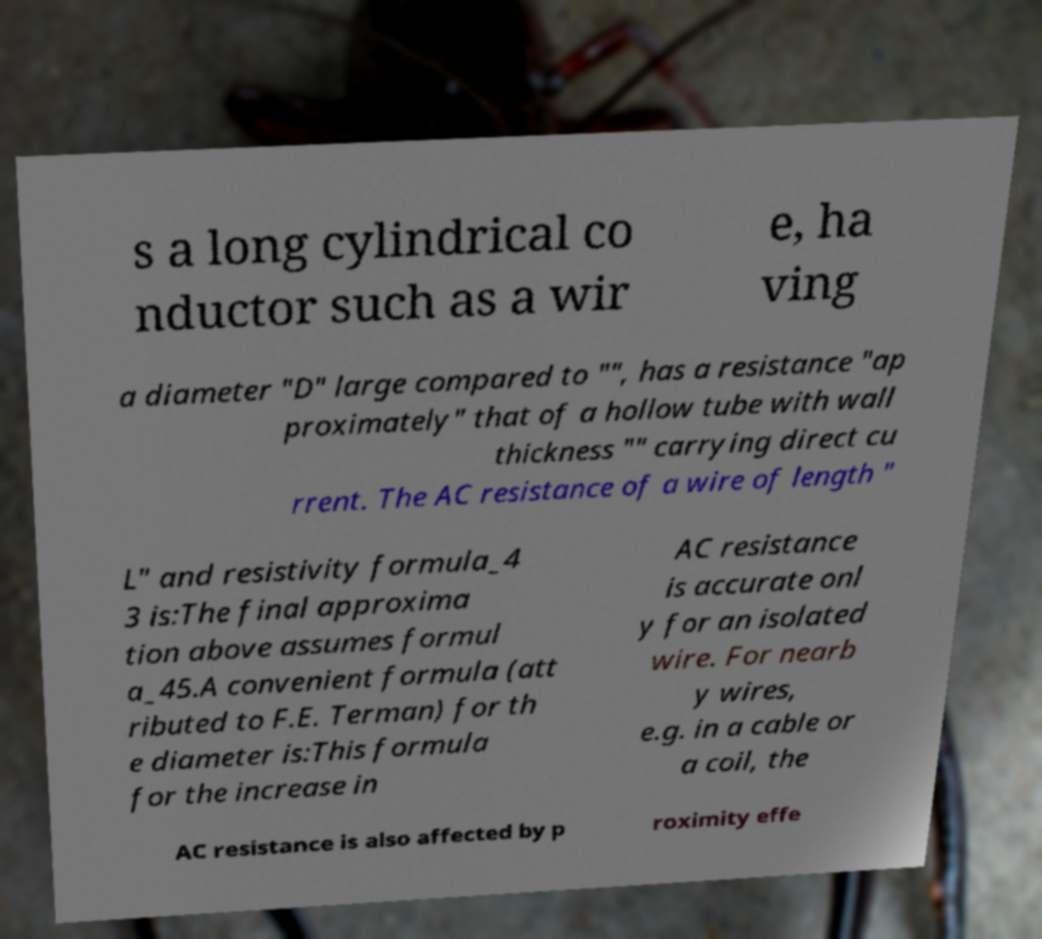Please identify and transcribe the text found in this image. s a long cylindrical co nductor such as a wir e, ha ving a diameter "D" large compared to "", has a resistance "ap proximately" that of a hollow tube with wall thickness "" carrying direct cu rrent. The AC resistance of a wire of length " L" and resistivity formula_4 3 is:The final approxima tion above assumes formul a_45.A convenient formula (att ributed to F.E. Terman) for th e diameter is:This formula for the increase in AC resistance is accurate onl y for an isolated wire. For nearb y wires, e.g. in a cable or a coil, the AC resistance is also affected by p roximity effe 